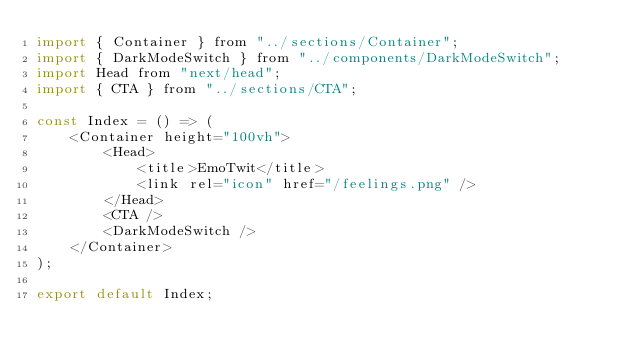<code> <loc_0><loc_0><loc_500><loc_500><_JavaScript_>import { Container } from "../sections/Container";
import { DarkModeSwitch } from "../components/DarkModeSwitch";
import Head from "next/head";
import { CTA } from "../sections/CTA";

const Index = () => (
	<Container height="100vh">
		<Head>
			<title>EmoTwit</title>
			<link rel="icon" href="/feelings.png" />
		</Head>
		<CTA />
		<DarkModeSwitch />
	</Container>
);

export default Index;
</code> 